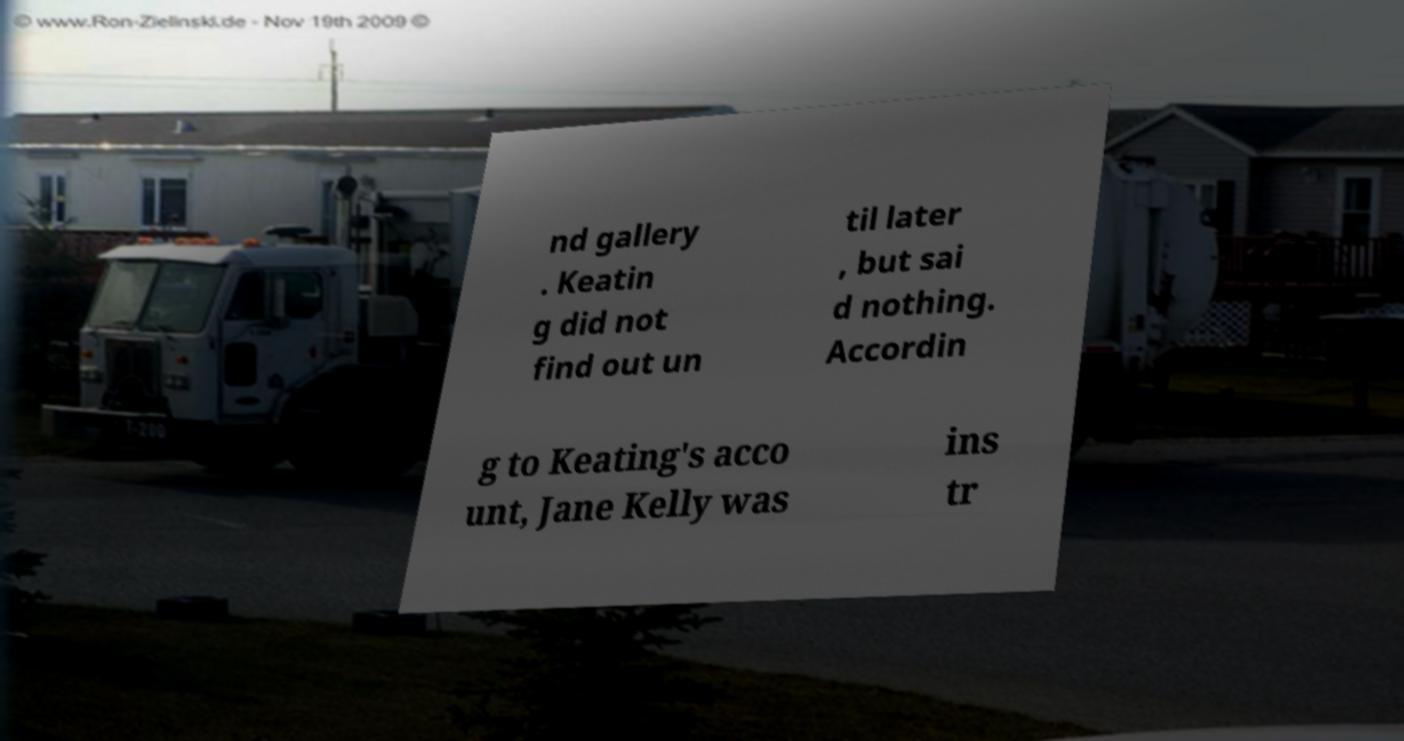I need the written content from this picture converted into text. Can you do that? nd gallery . Keatin g did not find out un til later , but sai d nothing. Accordin g to Keating's acco unt, Jane Kelly was ins tr 